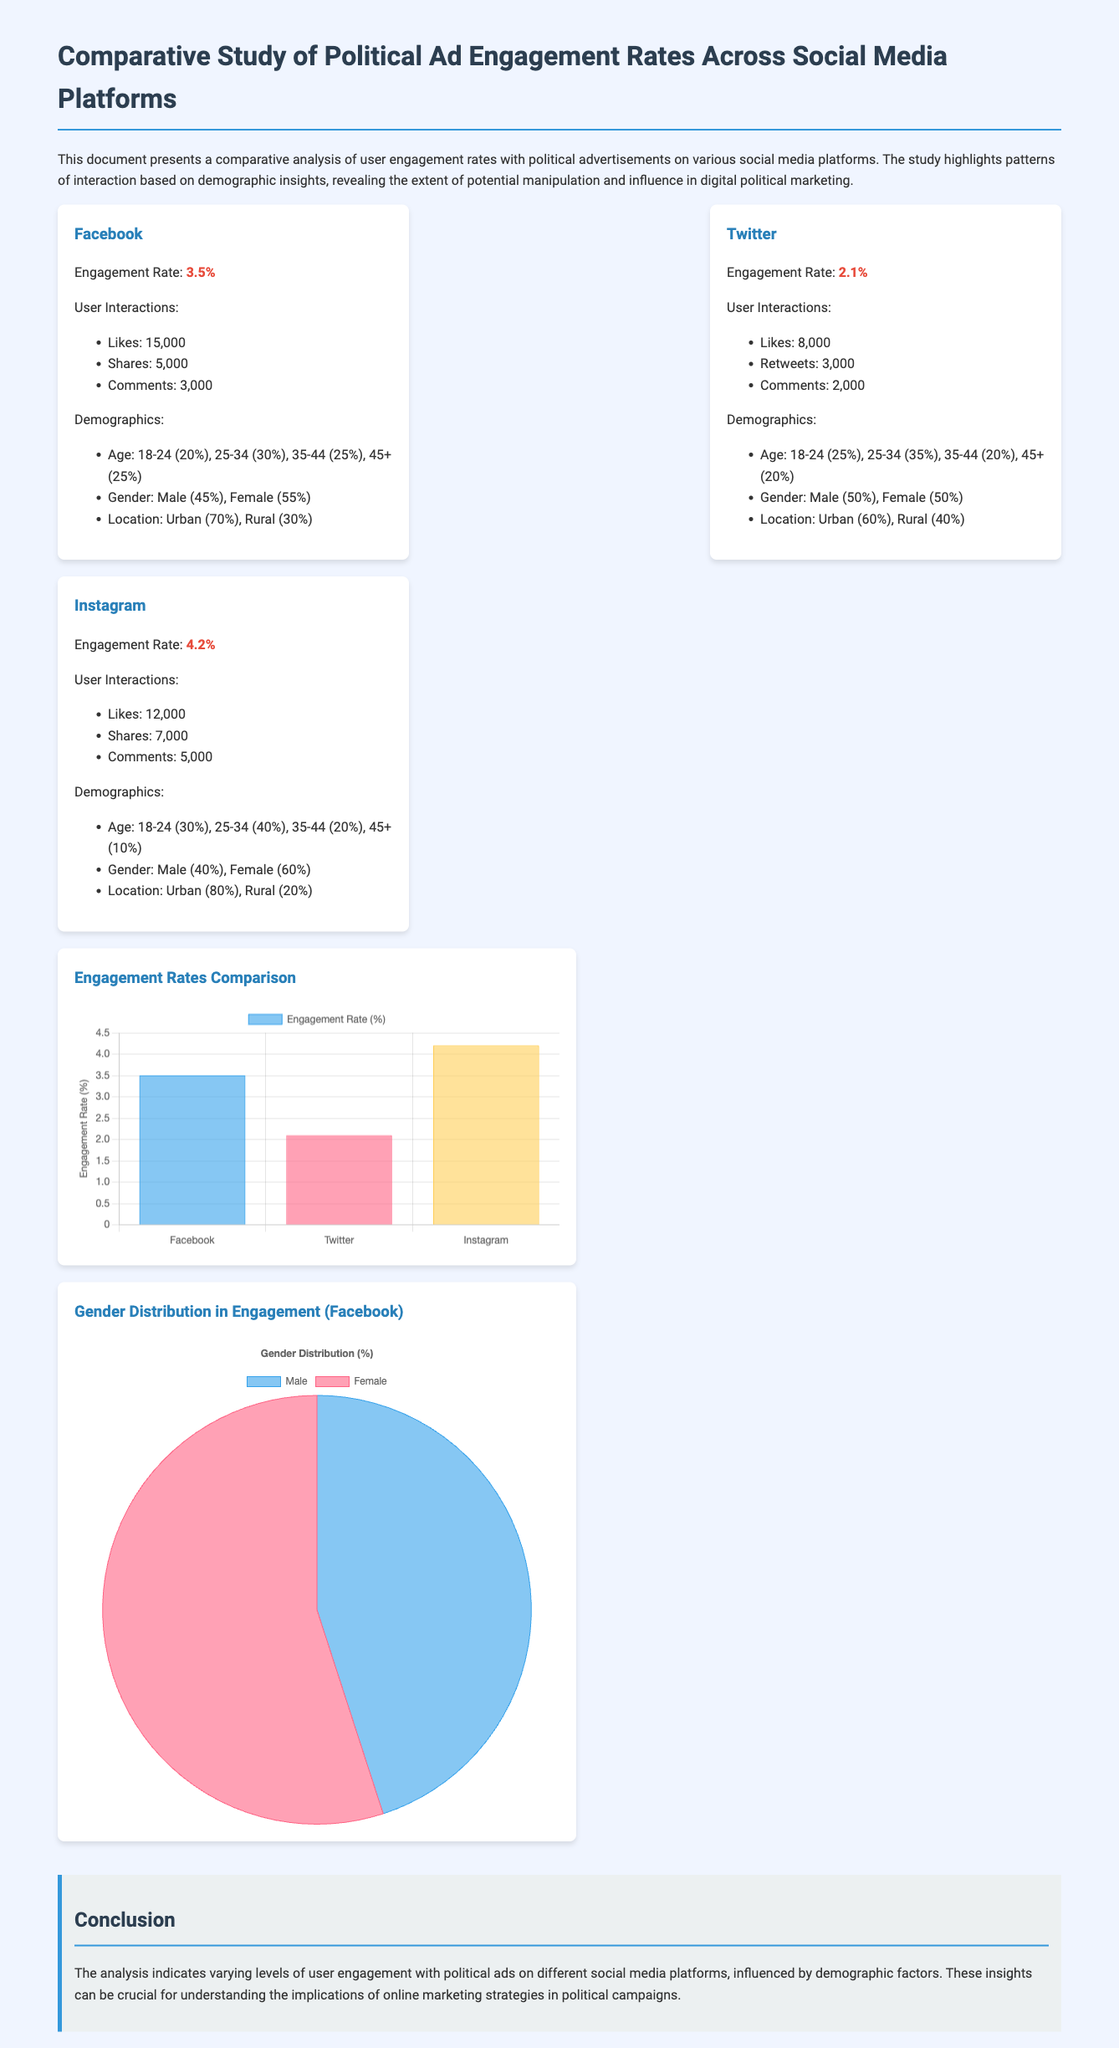What is the engagement rate for Facebook? The engagement rate for Facebook is provided in the document as 3.5%.
Answer: 3.5% Which platform has the highest engagement rate? Comparing the engagement rates given for Facebook, Twitter, and Instagram, Instagram has the highest engagement rate at 4.2%.
Answer: Instagram What percentage of Instagram users are aged 18-24? The document states that 30% of Instagram users are aged 18-24.
Answer: 30% How many likes did Twitter ads receive? The document indicates that Twitter ads received 8,000 likes.
Answer: 8,000 What is the male gender percentage for Facebook users? The document mentions that the male gender percentage for Facebook users is 45%.
Answer: 45% Which age group has the lowest percentage for Facebook engagement? The lowest age group percentage for Facebook engagement is 45+ at 25%.
Answer: 45+ What is the total number of shares for Instagram ads? The document lists the total shares for Instagram ads as 7,000.
Answer: 7,000 What is the user engagement rate for Twitter? The user engagement rate for Twitter is reported as 2.1%.
Answer: 2.1% How many user interactions does Facebook report in total? The document lists the total user interactions for Facebook as likes (15,000) + shares (5,000) + comments (3,000), totaling 23,000.
Answer: 23,000 